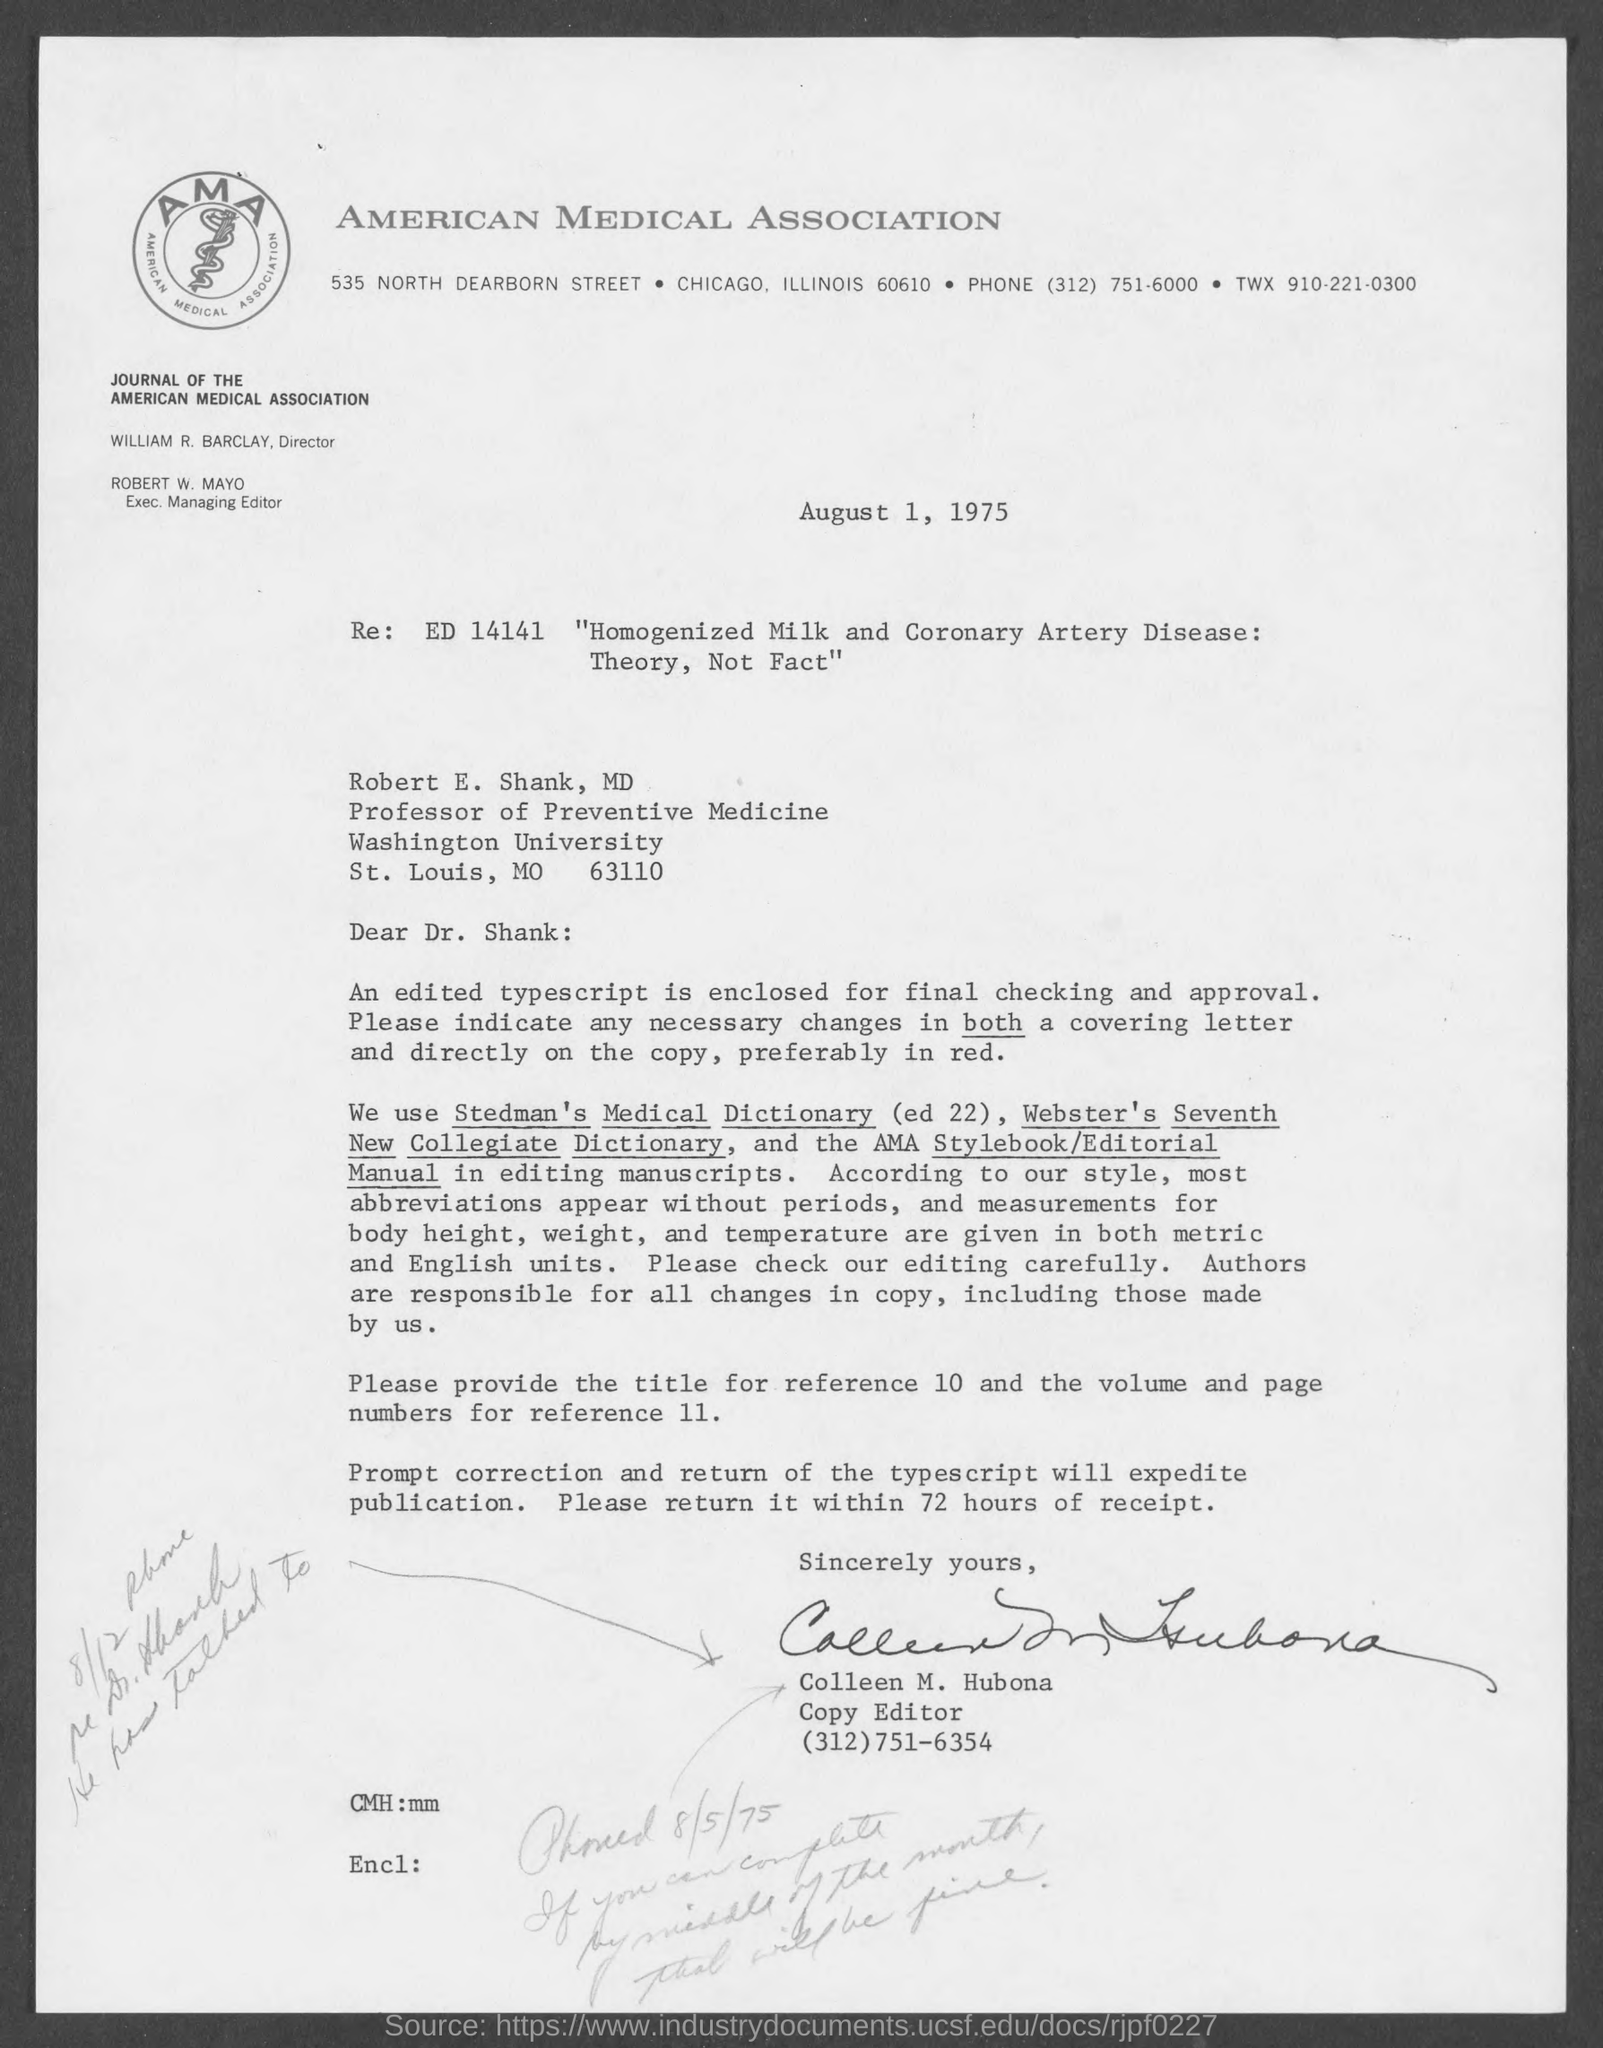Mention a couple of crucial points in this snapshot. The American Medical Association (AMA) is an organization of physicians in the United States. The letter was sent by Colleen M. Hubona. The measurements of body height, weight, and temperature utilize both metric and English units. 